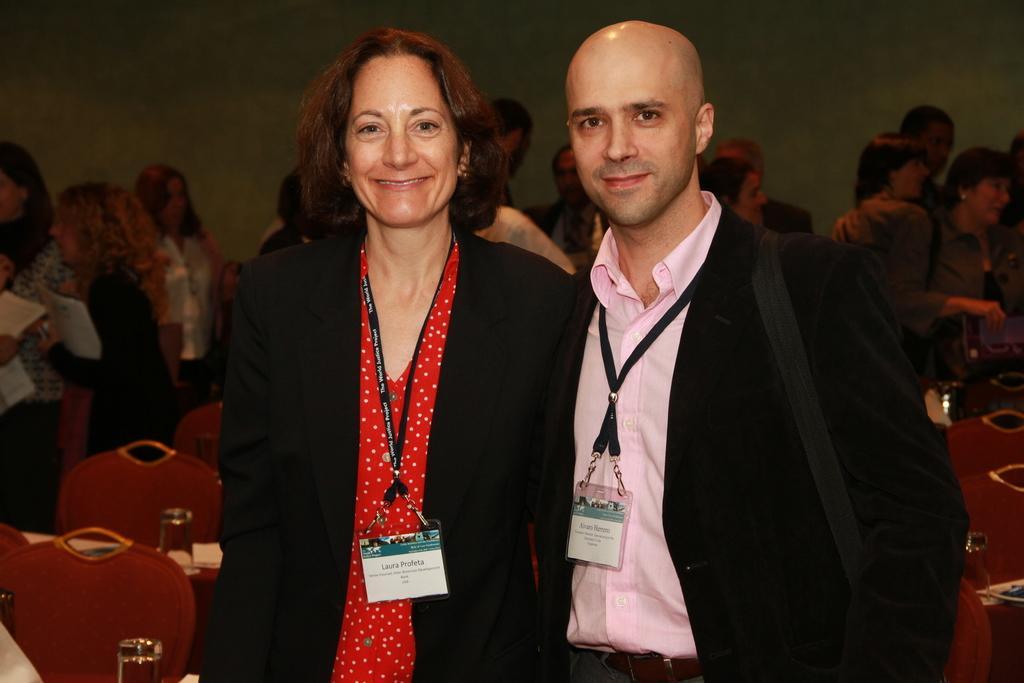How would you summarize this image in a sentence or two? In this image, there are a few people. We can see some chairs and objects like glasses. In the background, we can also see the wall. 